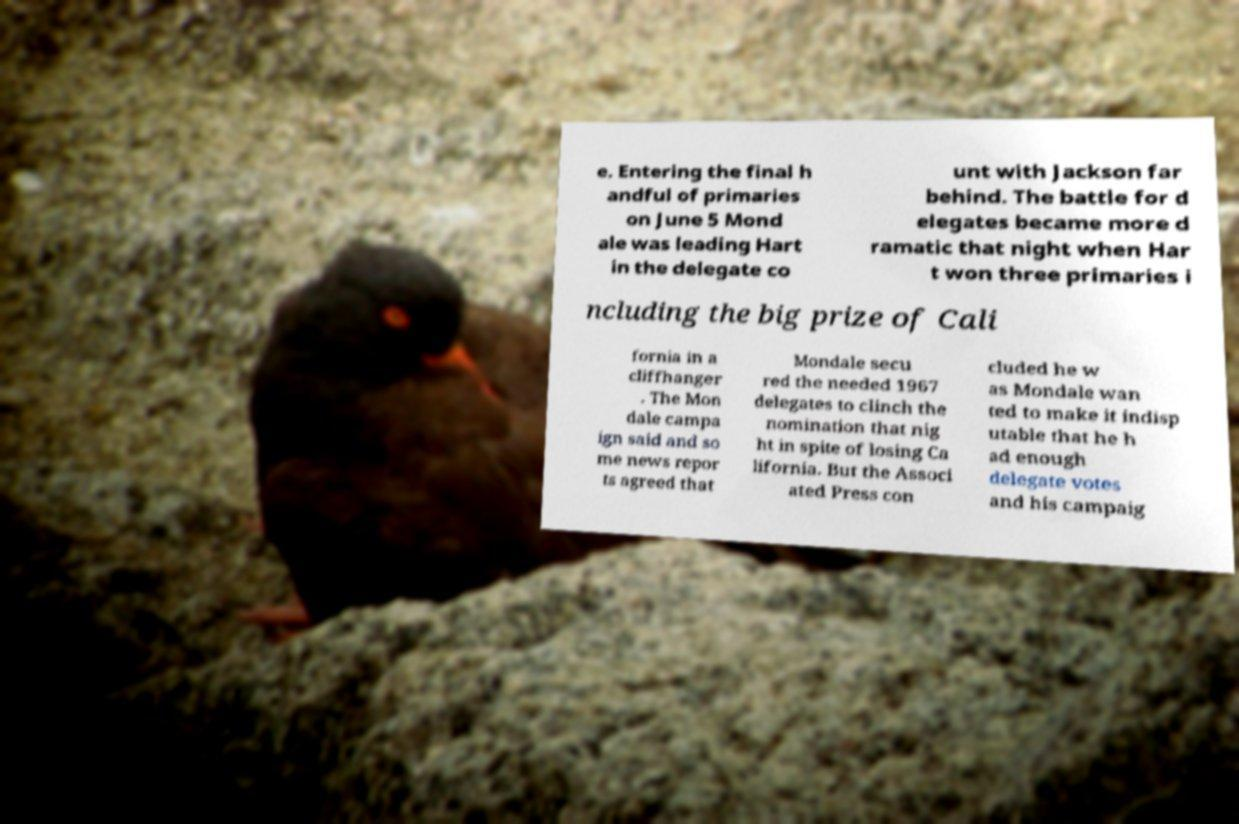Please read and relay the text visible in this image. What does it say? e. Entering the final h andful of primaries on June 5 Mond ale was leading Hart in the delegate co unt with Jackson far behind. The battle for d elegates became more d ramatic that night when Har t won three primaries i ncluding the big prize of Cali fornia in a cliffhanger . The Mon dale campa ign said and so me news repor ts agreed that Mondale secu red the needed 1967 delegates to clinch the nomination that nig ht in spite of losing Ca lifornia. But the Associ ated Press con cluded he w as Mondale wan ted to make it indisp utable that he h ad enough delegate votes and his campaig 